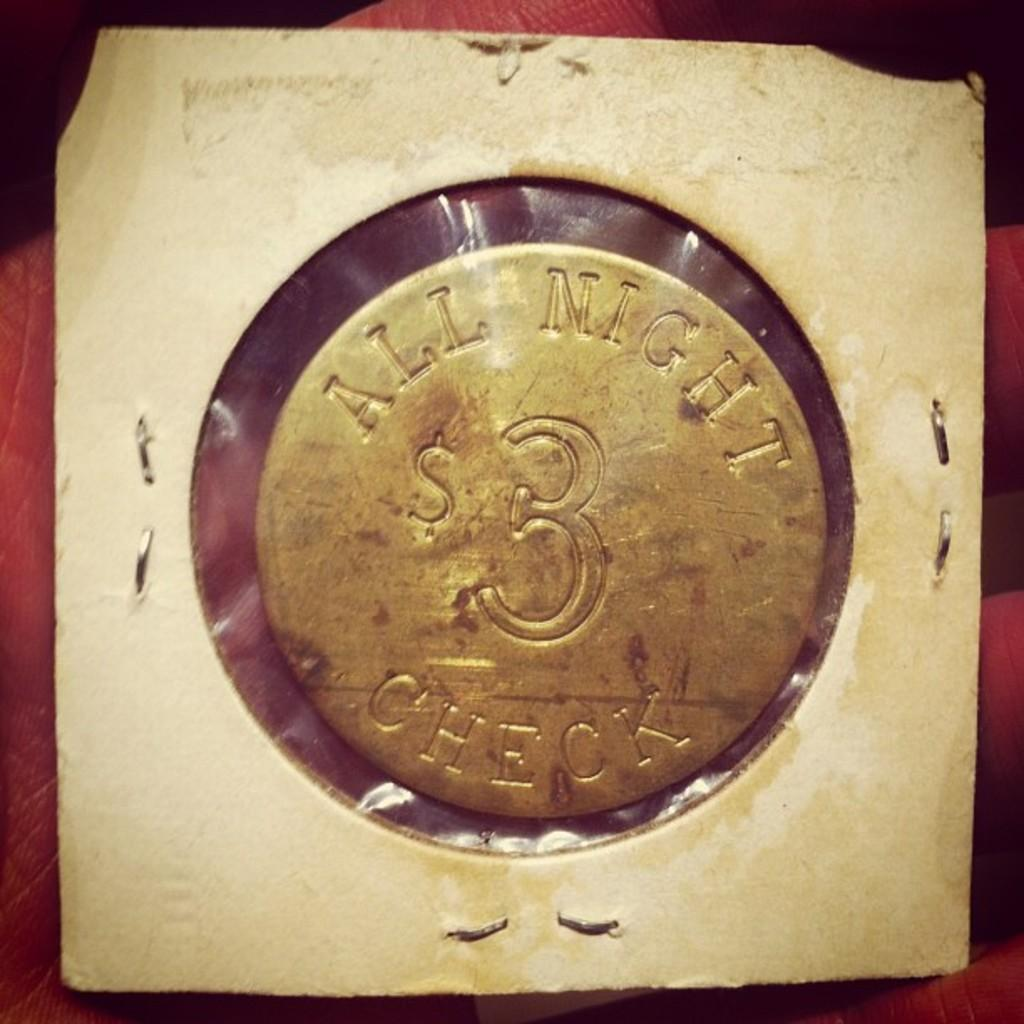<image>
Create a compact narrative representing the image presented. A vintage coin token that says "All Night Check $3" 